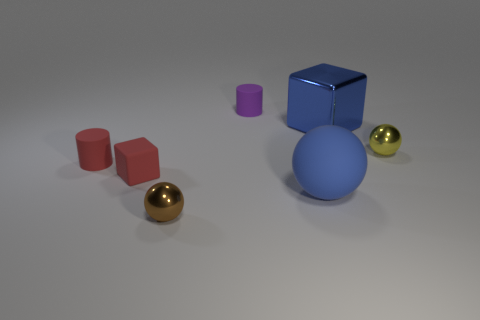Add 2 big blocks. How many objects exist? 9 Subtract all cylinders. How many objects are left? 5 Add 7 blue balls. How many blue balls exist? 8 Subtract 0 gray balls. How many objects are left? 7 Subtract all small blocks. Subtract all metal blocks. How many objects are left? 5 Add 4 small red cylinders. How many small red cylinders are left? 5 